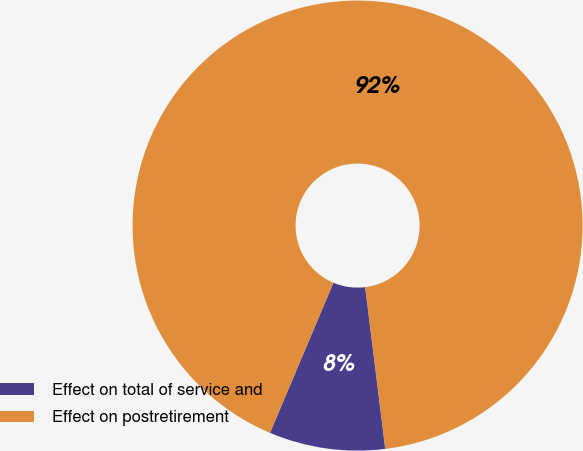Convert chart to OTSL. <chart><loc_0><loc_0><loc_500><loc_500><pie_chart><fcel>Effect on total of service and<fcel>Effect on postretirement<nl><fcel>8.33%<fcel>91.67%<nl></chart> 